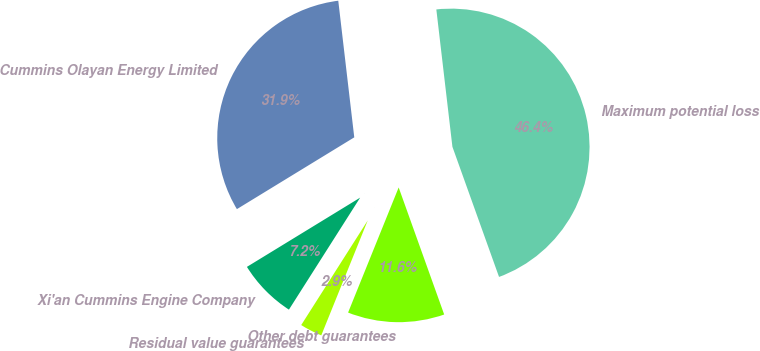<chart> <loc_0><loc_0><loc_500><loc_500><pie_chart><fcel>Cummins Olayan Energy Limited<fcel>Xi'an Cummins Engine Company<fcel>Residual value guarantees<fcel>Other debt guarantees<fcel>Maximum potential loss<nl><fcel>31.88%<fcel>7.25%<fcel>2.9%<fcel>11.59%<fcel>46.38%<nl></chart> 